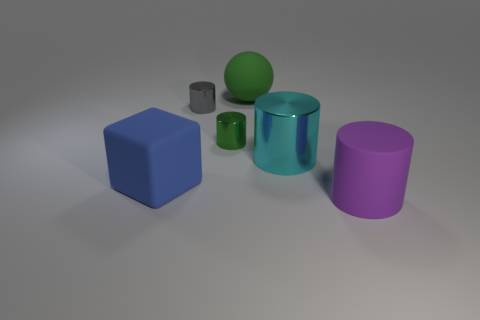How many tiny shiny cylinders are on the left side of the tiny green shiny thing?
Provide a short and direct response. 1. How many blocks are either purple rubber things or gray objects?
Provide a short and direct response. 0. There is a matte thing that is on the right side of the gray object and behind the purple cylinder; what size is it?
Offer a terse response. Large. How many other things are there of the same color as the big block?
Provide a succinct answer. 0. Do the large purple cylinder and the tiny cylinder that is left of the tiny green thing have the same material?
Keep it short and to the point. No. What number of things are metal cylinders in front of the gray cylinder or large green matte spheres?
Make the answer very short. 3. What is the shape of the metal object that is right of the tiny gray thing and to the left of the big green matte sphere?
Offer a very short reply. Cylinder. There is a gray cylinder that is made of the same material as the small green cylinder; what is its size?
Keep it short and to the point. Small. How many things are either small green cylinders on the left side of the big shiny cylinder or matte objects that are on the left side of the large purple matte thing?
Give a very brief answer. 3. Does the cylinder in front of the blue block have the same size as the tiny green thing?
Make the answer very short. No. 